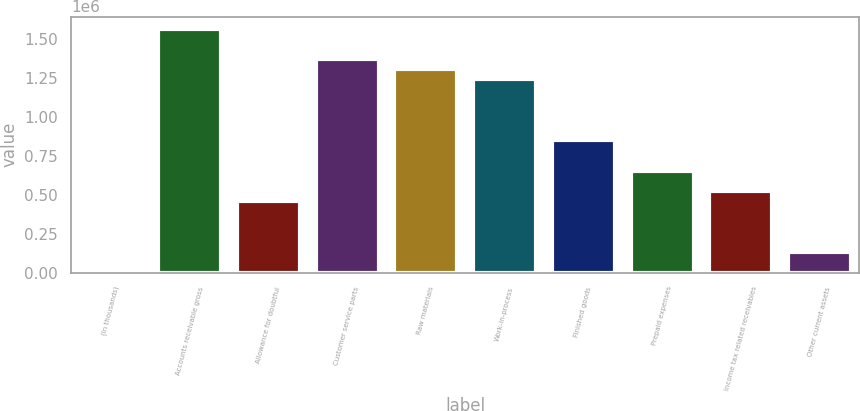Convert chart to OTSL. <chart><loc_0><loc_0><loc_500><loc_500><bar_chart><fcel>(In thousands)<fcel>Accounts receivable gross<fcel>Allowance for doubtful<fcel>Customer service parts<fcel>Raw materials<fcel>Work-in-process<fcel>Finished goods<fcel>Prepaid expenses<fcel>Income tax related receivables<fcel>Other current assets<nl><fcel>2017<fcel>1.56474e+06<fcel>457810<fcel>1.3694e+06<fcel>1.30428e+06<fcel>1.23917e+06<fcel>848490<fcel>653150<fcel>522923<fcel>132244<nl></chart> 